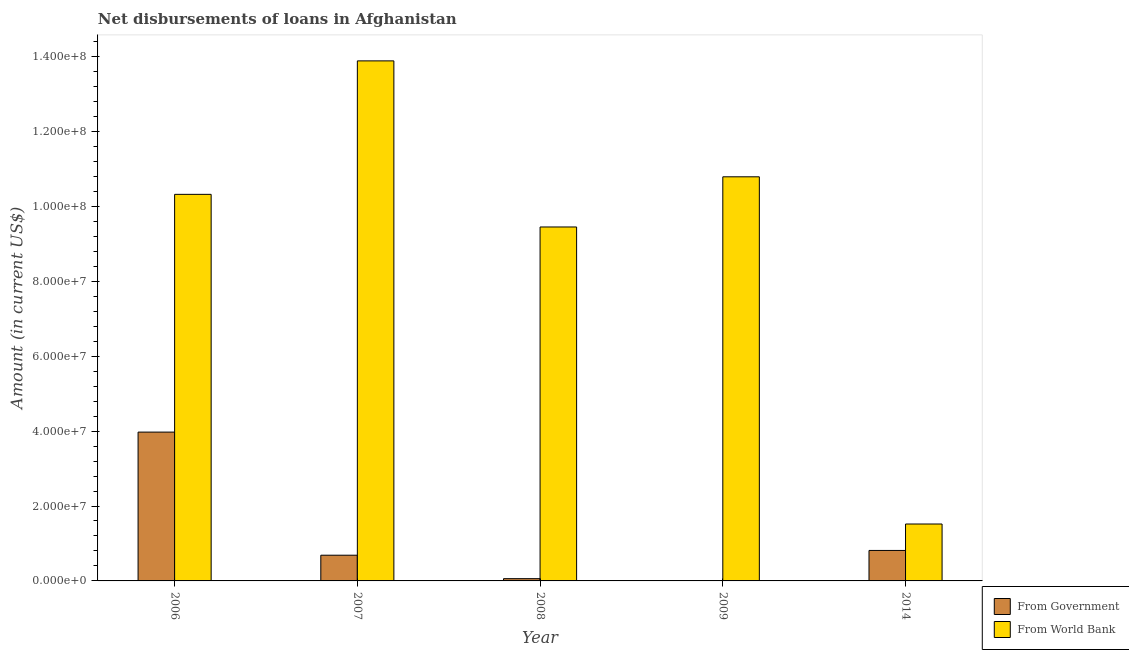Are the number of bars on each tick of the X-axis equal?
Keep it short and to the point. No. In how many cases, is the number of bars for a given year not equal to the number of legend labels?
Give a very brief answer. 1. What is the net disbursements of loan from world bank in 2008?
Ensure brevity in your answer.  9.45e+07. Across all years, what is the maximum net disbursements of loan from government?
Give a very brief answer. 3.97e+07. Across all years, what is the minimum net disbursements of loan from government?
Offer a very short reply. 0. In which year was the net disbursements of loan from world bank maximum?
Offer a very short reply. 2007. What is the total net disbursements of loan from government in the graph?
Your response must be concise. 5.53e+07. What is the difference between the net disbursements of loan from government in 2006 and that in 2014?
Your response must be concise. 3.16e+07. What is the difference between the net disbursements of loan from world bank in 2008 and the net disbursements of loan from government in 2007?
Give a very brief answer. -4.43e+07. What is the average net disbursements of loan from world bank per year?
Your response must be concise. 9.19e+07. What is the ratio of the net disbursements of loan from world bank in 2009 to that in 2014?
Make the answer very short. 7.1. Is the net disbursements of loan from world bank in 2006 less than that in 2007?
Your answer should be compact. Yes. Is the difference between the net disbursements of loan from world bank in 2006 and 2014 greater than the difference between the net disbursements of loan from government in 2006 and 2014?
Ensure brevity in your answer.  No. What is the difference between the highest and the second highest net disbursements of loan from world bank?
Provide a succinct answer. 3.10e+07. What is the difference between the highest and the lowest net disbursements of loan from world bank?
Make the answer very short. 1.24e+08. Is the sum of the net disbursements of loan from world bank in 2006 and 2009 greater than the maximum net disbursements of loan from government across all years?
Give a very brief answer. Yes. Are all the bars in the graph horizontal?
Offer a very short reply. No. What is the difference between two consecutive major ticks on the Y-axis?
Provide a succinct answer. 2.00e+07. Are the values on the major ticks of Y-axis written in scientific E-notation?
Your response must be concise. Yes. Does the graph contain any zero values?
Ensure brevity in your answer.  Yes. How are the legend labels stacked?
Offer a terse response. Vertical. What is the title of the graph?
Offer a very short reply. Net disbursements of loans in Afghanistan. What is the label or title of the X-axis?
Provide a short and direct response. Year. What is the Amount (in current US$) of From Government in 2006?
Ensure brevity in your answer.  3.97e+07. What is the Amount (in current US$) of From World Bank in 2006?
Make the answer very short. 1.03e+08. What is the Amount (in current US$) in From Government in 2007?
Provide a succinct answer. 6.86e+06. What is the Amount (in current US$) in From World Bank in 2007?
Keep it short and to the point. 1.39e+08. What is the Amount (in current US$) of From Government in 2008?
Offer a very short reply. 6.04e+05. What is the Amount (in current US$) in From World Bank in 2008?
Offer a very short reply. 9.45e+07. What is the Amount (in current US$) of From World Bank in 2009?
Give a very brief answer. 1.08e+08. What is the Amount (in current US$) in From Government in 2014?
Ensure brevity in your answer.  8.14e+06. What is the Amount (in current US$) of From World Bank in 2014?
Make the answer very short. 1.52e+07. Across all years, what is the maximum Amount (in current US$) in From Government?
Keep it short and to the point. 3.97e+07. Across all years, what is the maximum Amount (in current US$) in From World Bank?
Your response must be concise. 1.39e+08. Across all years, what is the minimum Amount (in current US$) of From Government?
Your answer should be very brief. 0. Across all years, what is the minimum Amount (in current US$) of From World Bank?
Your answer should be compact. 1.52e+07. What is the total Amount (in current US$) of From Government in the graph?
Offer a terse response. 5.53e+07. What is the total Amount (in current US$) of From World Bank in the graph?
Your answer should be compact. 4.60e+08. What is the difference between the Amount (in current US$) of From Government in 2006 and that in 2007?
Give a very brief answer. 3.29e+07. What is the difference between the Amount (in current US$) of From World Bank in 2006 and that in 2007?
Ensure brevity in your answer.  -3.56e+07. What is the difference between the Amount (in current US$) of From Government in 2006 and that in 2008?
Your answer should be very brief. 3.91e+07. What is the difference between the Amount (in current US$) in From World Bank in 2006 and that in 2008?
Give a very brief answer. 8.71e+06. What is the difference between the Amount (in current US$) of From World Bank in 2006 and that in 2009?
Ensure brevity in your answer.  -4.68e+06. What is the difference between the Amount (in current US$) in From Government in 2006 and that in 2014?
Your answer should be compact. 3.16e+07. What is the difference between the Amount (in current US$) of From World Bank in 2006 and that in 2014?
Ensure brevity in your answer.  8.80e+07. What is the difference between the Amount (in current US$) of From Government in 2007 and that in 2008?
Make the answer very short. 6.26e+06. What is the difference between the Amount (in current US$) of From World Bank in 2007 and that in 2008?
Ensure brevity in your answer.  4.43e+07. What is the difference between the Amount (in current US$) in From World Bank in 2007 and that in 2009?
Provide a succinct answer. 3.10e+07. What is the difference between the Amount (in current US$) in From Government in 2007 and that in 2014?
Your response must be concise. -1.27e+06. What is the difference between the Amount (in current US$) in From World Bank in 2007 and that in 2014?
Provide a short and direct response. 1.24e+08. What is the difference between the Amount (in current US$) in From World Bank in 2008 and that in 2009?
Ensure brevity in your answer.  -1.34e+07. What is the difference between the Amount (in current US$) of From Government in 2008 and that in 2014?
Offer a terse response. -7.53e+06. What is the difference between the Amount (in current US$) of From World Bank in 2008 and that in 2014?
Provide a succinct answer. 7.93e+07. What is the difference between the Amount (in current US$) of From World Bank in 2009 and that in 2014?
Your answer should be compact. 9.27e+07. What is the difference between the Amount (in current US$) in From Government in 2006 and the Amount (in current US$) in From World Bank in 2007?
Make the answer very short. -9.91e+07. What is the difference between the Amount (in current US$) in From Government in 2006 and the Amount (in current US$) in From World Bank in 2008?
Your answer should be compact. -5.48e+07. What is the difference between the Amount (in current US$) of From Government in 2006 and the Amount (in current US$) of From World Bank in 2009?
Offer a terse response. -6.82e+07. What is the difference between the Amount (in current US$) in From Government in 2006 and the Amount (in current US$) in From World Bank in 2014?
Offer a very short reply. 2.45e+07. What is the difference between the Amount (in current US$) of From Government in 2007 and the Amount (in current US$) of From World Bank in 2008?
Make the answer very short. -8.76e+07. What is the difference between the Amount (in current US$) in From Government in 2007 and the Amount (in current US$) in From World Bank in 2009?
Make the answer very short. -1.01e+08. What is the difference between the Amount (in current US$) of From Government in 2007 and the Amount (in current US$) of From World Bank in 2014?
Offer a terse response. -8.33e+06. What is the difference between the Amount (in current US$) of From Government in 2008 and the Amount (in current US$) of From World Bank in 2009?
Keep it short and to the point. -1.07e+08. What is the difference between the Amount (in current US$) of From Government in 2008 and the Amount (in current US$) of From World Bank in 2014?
Ensure brevity in your answer.  -1.46e+07. What is the average Amount (in current US$) of From Government per year?
Your response must be concise. 1.11e+07. What is the average Amount (in current US$) in From World Bank per year?
Offer a terse response. 9.19e+07. In the year 2006, what is the difference between the Amount (in current US$) of From Government and Amount (in current US$) of From World Bank?
Offer a terse response. -6.35e+07. In the year 2007, what is the difference between the Amount (in current US$) in From Government and Amount (in current US$) in From World Bank?
Make the answer very short. -1.32e+08. In the year 2008, what is the difference between the Amount (in current US$) in From Government and Amount (in current US$) in From World Bank?
Provide a short and direct response. -9.39e+07. In the year 2014, what is the difference between the Amount (in current US$) in From Government and Amount (in current US$) in From World Bank?
Keep it short and to the point. -7.06e+06. What is the ratio of the Amount (in current US$) of From Government in 2006 to that in 2007?
Make the answer very short. 5.79. What is the ratio of the Amount (in current US$) in From World Bank in 2006 to that in 2007?
Give a very brief answer. 0.74. What is the ratio of the Amount (in current US$) in From Government in 2006 to that in 2008?
Your response must be concise. 65.78. What is the ratio of the Amount (in current US$) in From World Bank in 2006 to that in 2008?
Offer a very short reply. 1.09. What is the ratio of the Amount (in current US$) in From World Bank in 2006 to that in 2009?
Your answer should be very brief. 0.96. What is the ratio of the Amount (in current US$) of From Government in 2006 to that in 2014?
Provide a short and direct response. 4.88. What is the ratio of the Amount (in current US$) of From World Bank in 2006 to that in 2014?
Offer a very short reply. 6.79. What is the ratio of the Amount (in current US$) of From Government in 2007 to that in 2008?
Keep it short and to the point. 11.37. What is the ratio of the Amount (in current US$) of From World Bank in 2007 to that in 2008?
Provide a short and direct response. 1.47. What is the ratio of the Amount (in current US$) in From World Bank in 2007 to that in 2009?
Ensure brevity in your answer.  1.29. What is the ratio of the Amount (in current US$) of From Government in 2007 to that in 2014?
Ensure brevity in your answer.  0.84. What is the ratio of the Amount (in current US$) of From World Bank in 2007 to that in 2014?
Provide a short and direct response. 9.14. What is the ratio of the Amount (in current US$) in From World Bank in 2008 to that in 2009?
Offer a very short reply. 0.88. What is the ratio of the Amount (in current US$) in From Government in 2008 to that in 2014?
Your answer should be compact. 0.07. What is the ratio of the Amount (in current US$) in From World Bank in 2008 to that in 2014?
Provide a succinct answer. 6.22. What is the ratio of the Amount (in current US$) of From World Bank in 2009 to that in 2014?
Keep it short and to the point. 7.1. What is the difference between the highest and the second highest Amount (in current US$) of From Government?
Offer a very short reply. 3.16e+07. What is the difference between the highest and the second highest Amount (in current US$) of From World Bank?
Make the answer very short. 3.10e+07. What is the difference between the highest and the lowest Amount (in current US$) of From Government?
Keep it short and to the point. 3.97e+07. What is the difference between the highest and the lowest Amount (in current US$) in From World Bank?
Ensure brevity in your answer.  1.24e+08. 